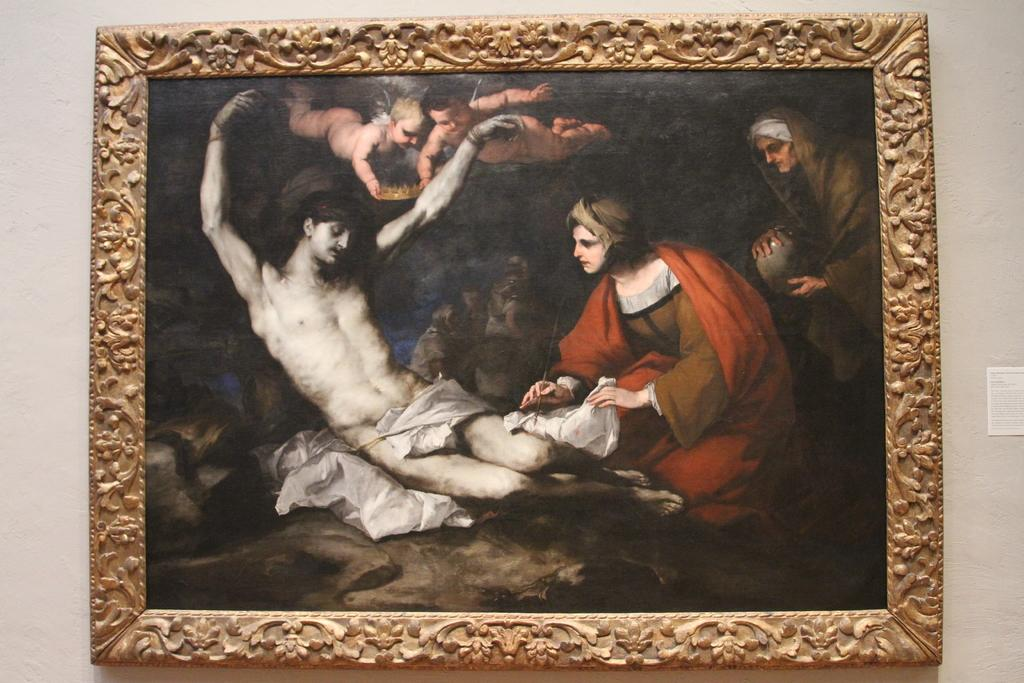What is hanging on the wall in the image? There is a frame on the wall in the image. What is inside the frame? The frame contains a painting. What is the subject matter of the painting? The painting depicts persons. What type of cream is being used to create the effect of a blade in the painting? There is no cream, effect, or blade present in the image. The painting depicts persons, and there is no indication of any cream, effect, or blade being used in the painting. 